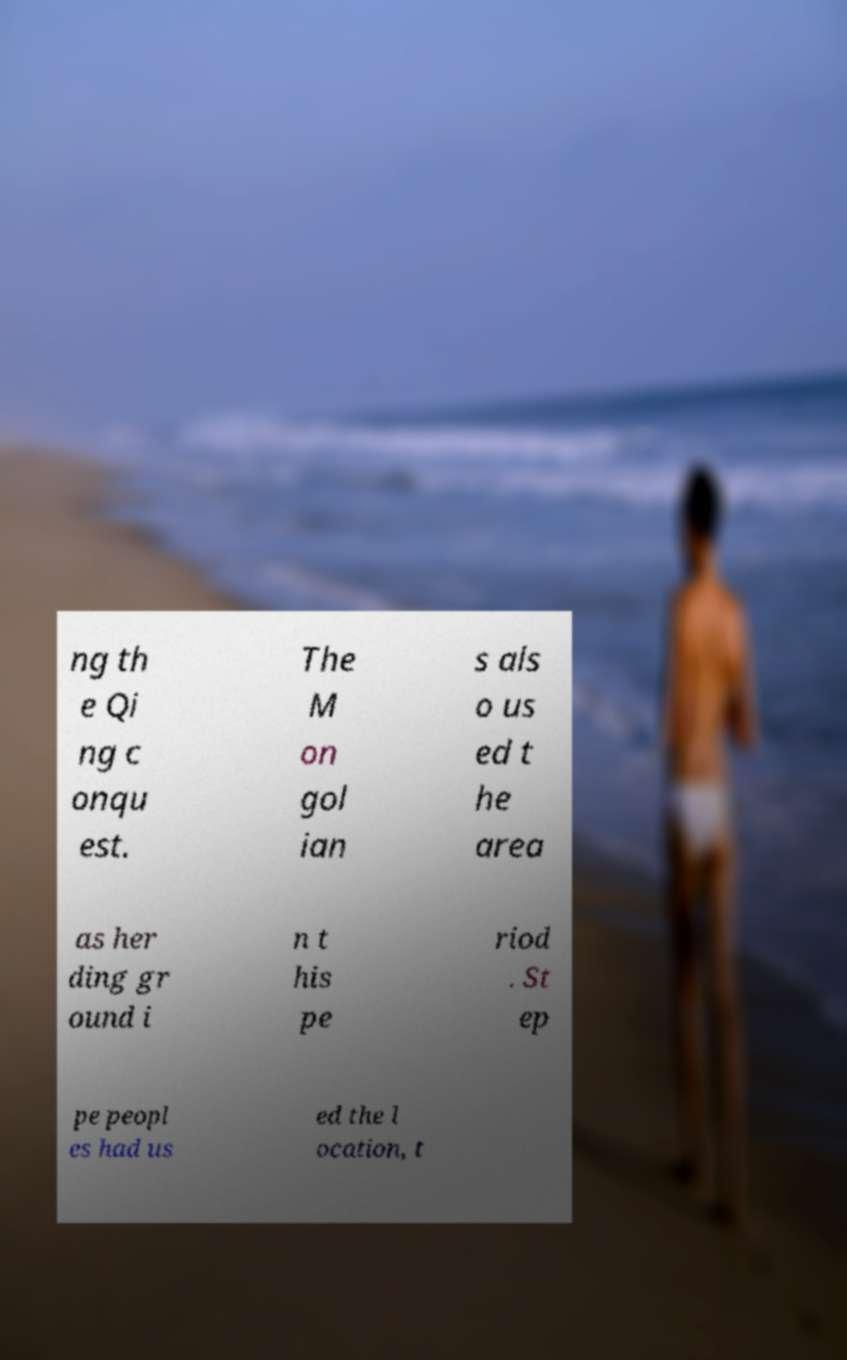Can you read and provide the text displayed in the image?This photo seems to have some interesting text. Can you extract and type it out for me? ng th e Qi ng c onqu est. The M on gol ian s als o us ed t he area as her ding gr ound i n t his pe riod . St ep pe peopl es had us ed the l ocation, t 